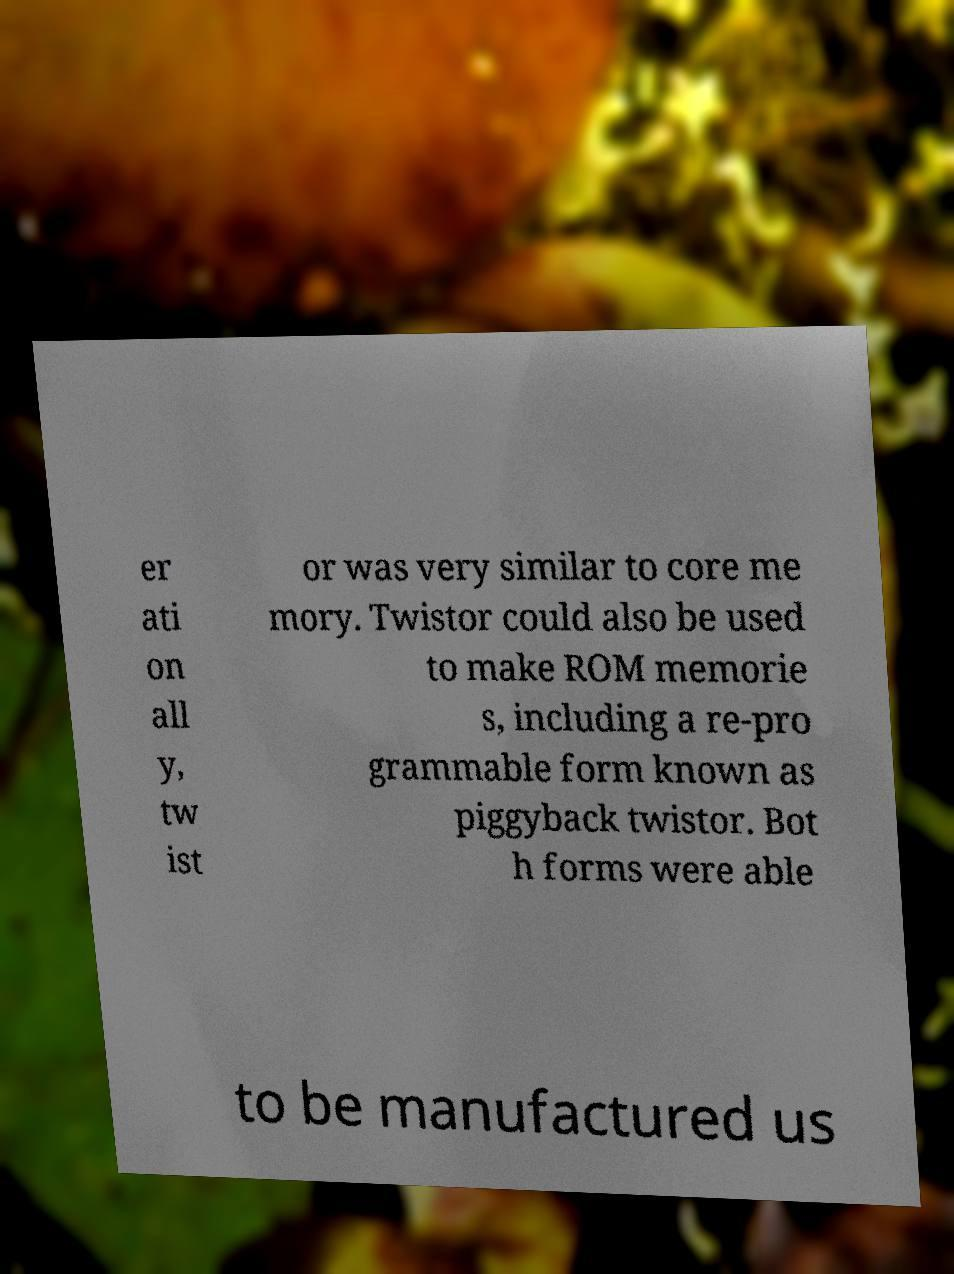For documentation purposes, I need the text within this image transcribed. Could you provide that? er ati on all y, tw ist or was very similar to core me mory. Twistor could also be used to make ROM memorie s, including a re-pro grammable form known as piggyback twistor. Bot h forms were able to be manufactured us 